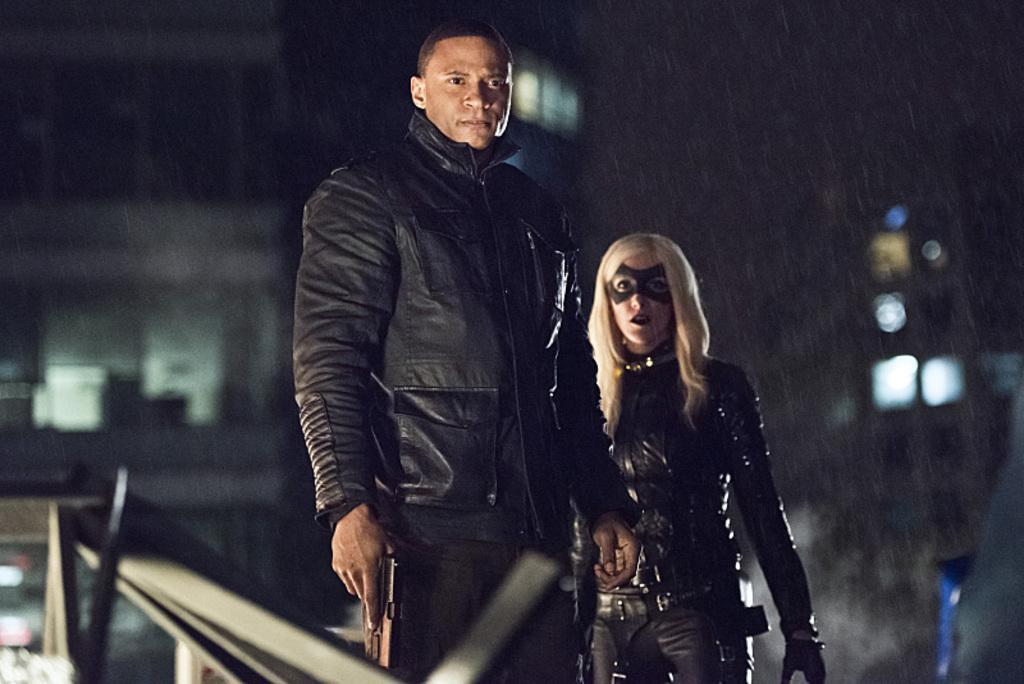Describe this image in one or two sentences. In this image, we can see a few people. Among them, we can see a person holding a gun. We can also see the blurred background with some lights. We can see some objects on the left. 